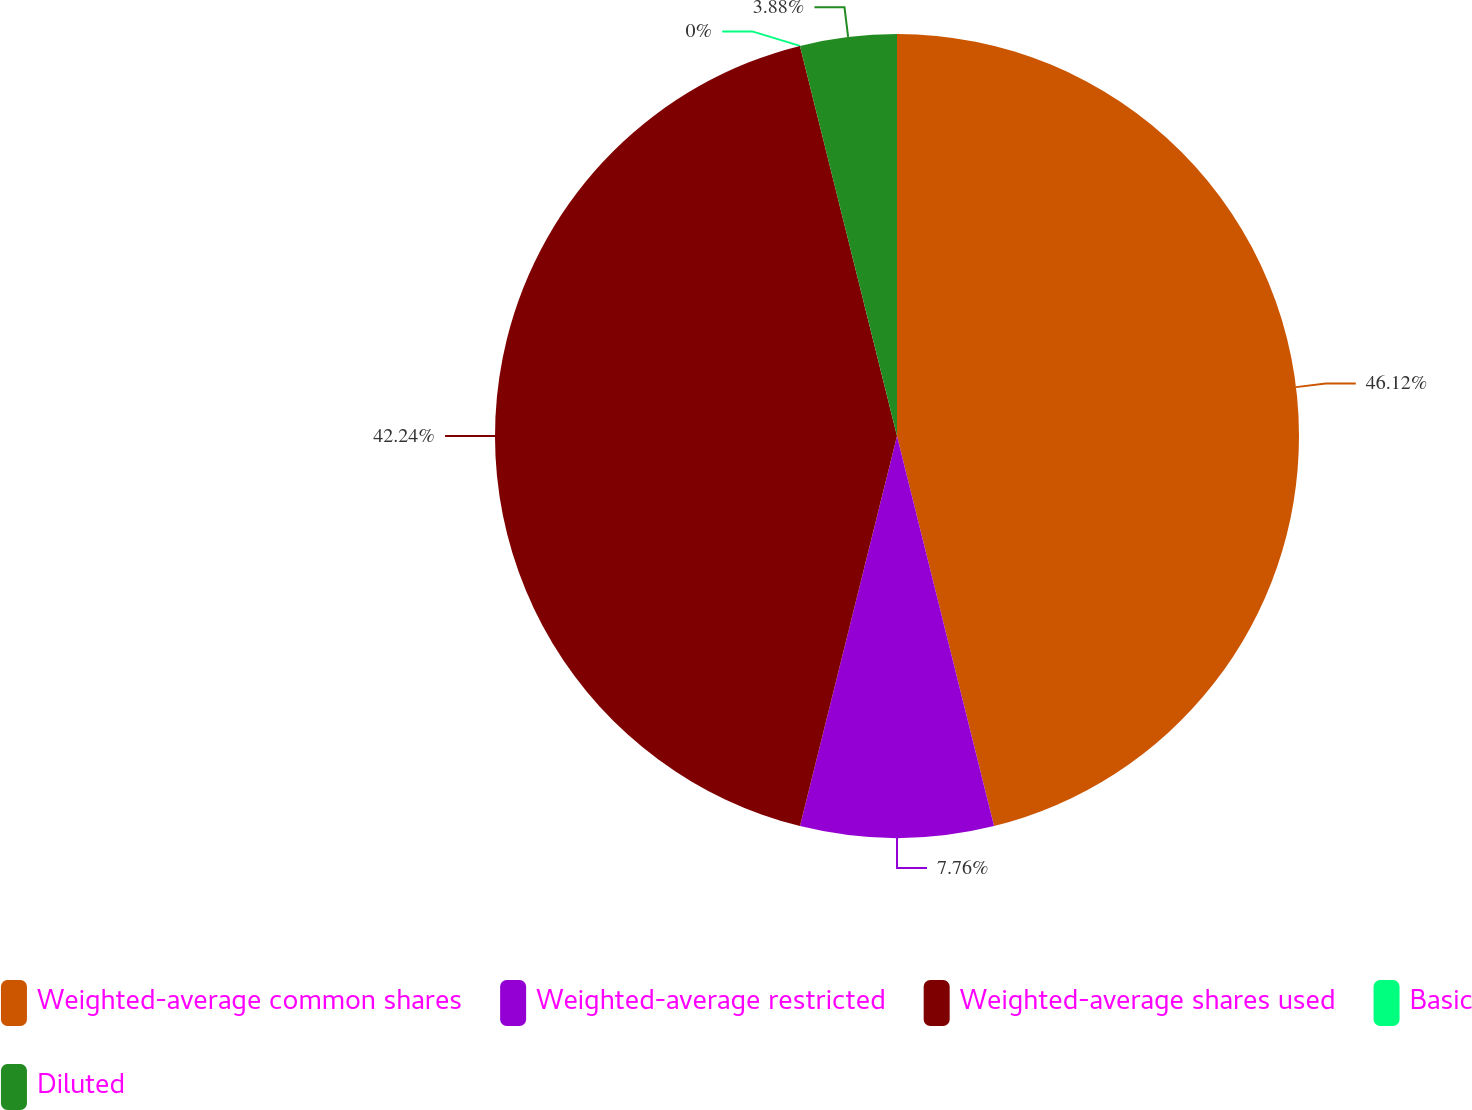Convert chart. <chart><loc_0><loc_0><loc_500><loc_500><pie_chart><fcel>Weighted-average common shares<fcel>Weighted-average restricted<fcel>Weighted-average shares used<fcel>Basic<fcel>Diluted<nl><fcel>46.12%<fcel>7.76%<fcel>42.24%<fcel>0.0%<fcel>3.88%<nl></chart> 